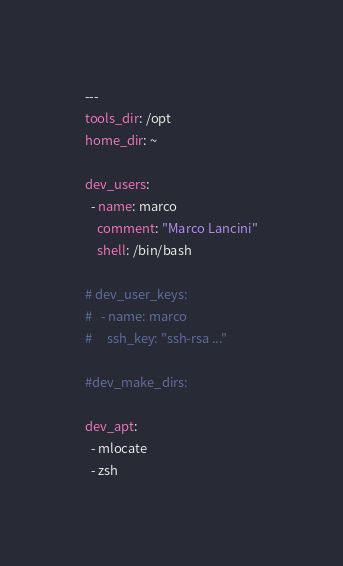<code> <loc_0><loc_0><loc_500><loc_500><_YAML_>---
tools_dir: /opt
home_dir: ~

dev_users:
  - name: marco
    comment: "Marco Lancini"
    shell: /bin/bash

# dev_user_keys:
#   - name: marco
#     ssh_key: "ssh-rsa ..."

#dev_make_dirs:

dev_apt:
  - mlocate
  - zsh</code> 